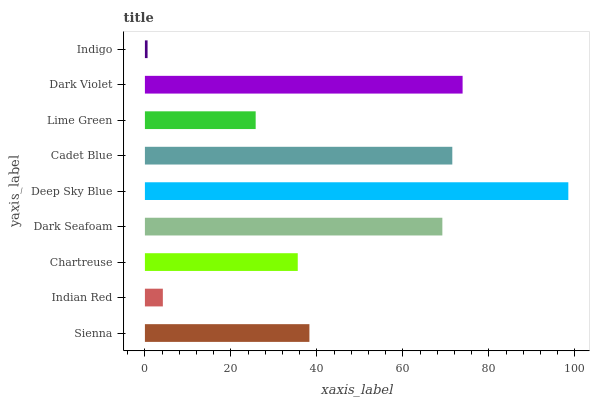Is Indigo the minimum?
Answer yes or no. Yes. Is Deep Sky Blue the maximum?
Answer yes or no. Yes. Is Indian Red the minimum?
Answer yes or no. No. Is Indian Red the maximum?
Answer yes or no. No. Is Sienna greater than Indian Red?
Answer yes or no. Yes. Is Indian Red less than Sienna?
Answer yes or no. Yes. Is Indian Red greater than Sienna?
Answer yes or no. No. Is Sienna less than Indian Red?
Answer yes or no. No. Is Sienna the high median?
Answer yes or no. Yes. Is Sienna the low median?
Answer yes or no. Yes. Is Deep Sky Blue the high median?
Answer yes or no. No. Is Deep Sky Blue the low median?
Answer yes or no. No. 